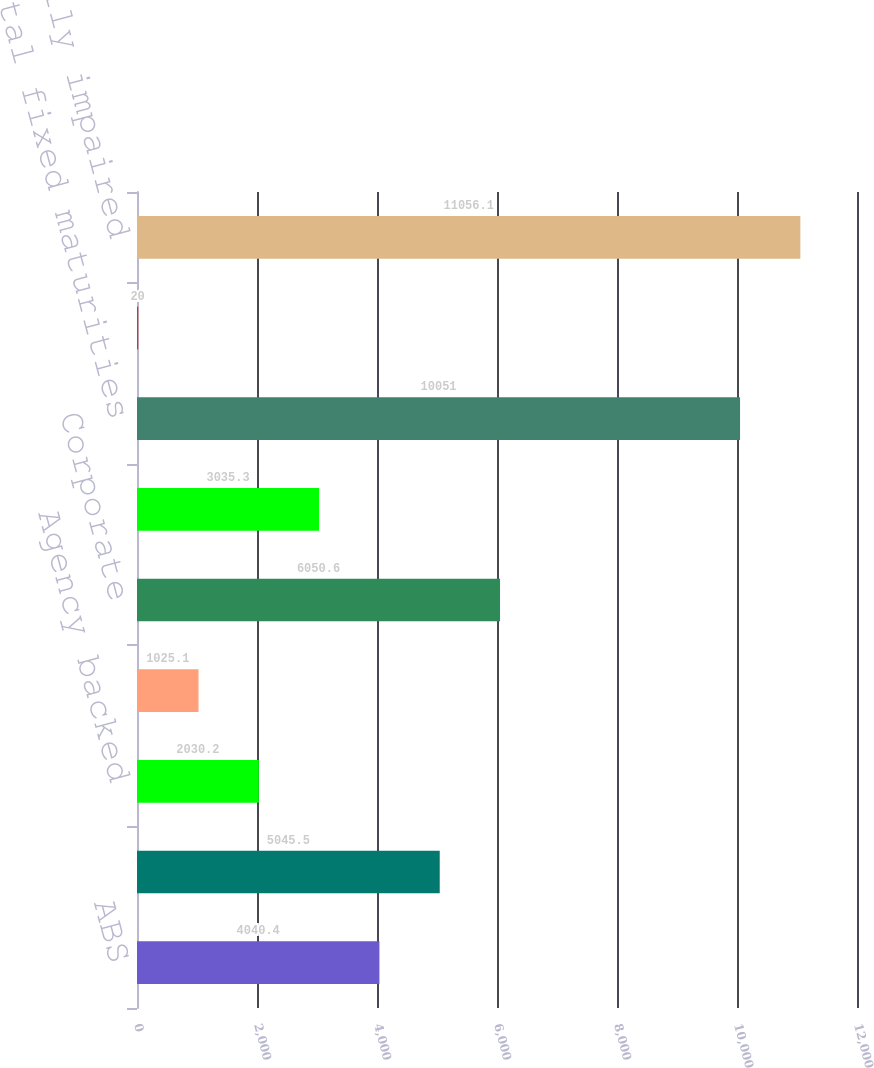<chart> <loc_0><loc_0><loc_500><loc_500><bar_chart><fcel>ABS<fcel>CMBS - Non-agency backed<fcel>Agency backed<fcel>Non-agency backed<fcel>Corporate<fcel>States municipalities and<fcel>Total fixed maturities<fcel>Equity securities available-<fcel>Total temporarily impaired<nl><fcel>4040.4<fcel>5045.5<fcel>2030.2<fcel>1025.1<fcel>6050.6<fcel>3035.3<fcel>10051<fcel>20<fcel>11056.1<nl></chart> 